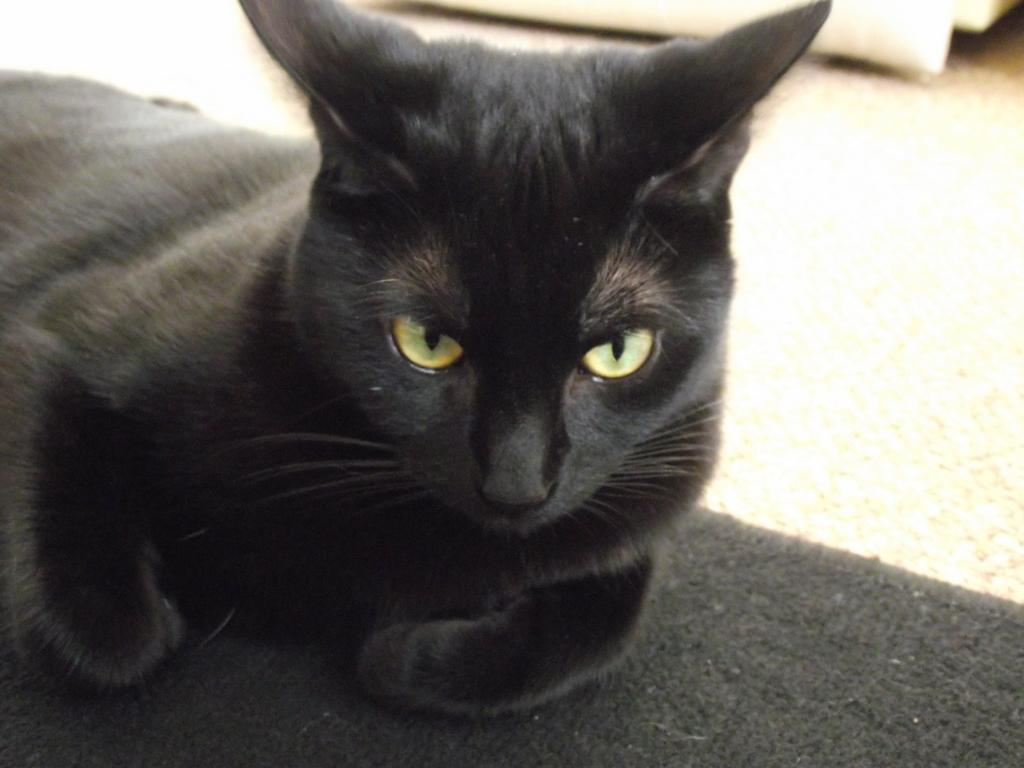What animal is present in the image? There is a cat in the image. Where is the cat located? The cat is on a mat. What can be seen in the background of the image? There is a floor visible in the background of the image. What level of pollution is present in the image? There is no information about pollution in the image, as it features a cat on a mat with a visible floor in the background. 